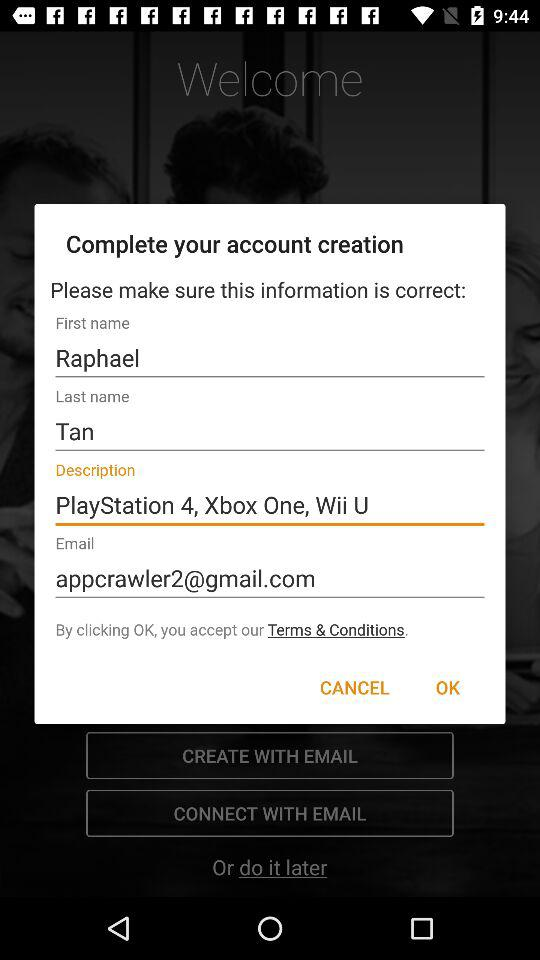What is the last name? The last name is Tan. 